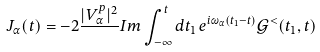Convert formula to latex. <formula><loc_0><loc_0><loc_500><loc_500>J _ { \alpha } ( t ) = - 2 \frac { | V _ { \alpha } ^ { p } | ^ { 2 } } { } I m \int _ { - \infty } ^ { t } d t _ { 1 } \, e ^ { i \omega _ { \alpha } ( t _ { 1 } - t ) } \mathcal { G } ^ { < } ( t _ { 1 } , t )</formula> 